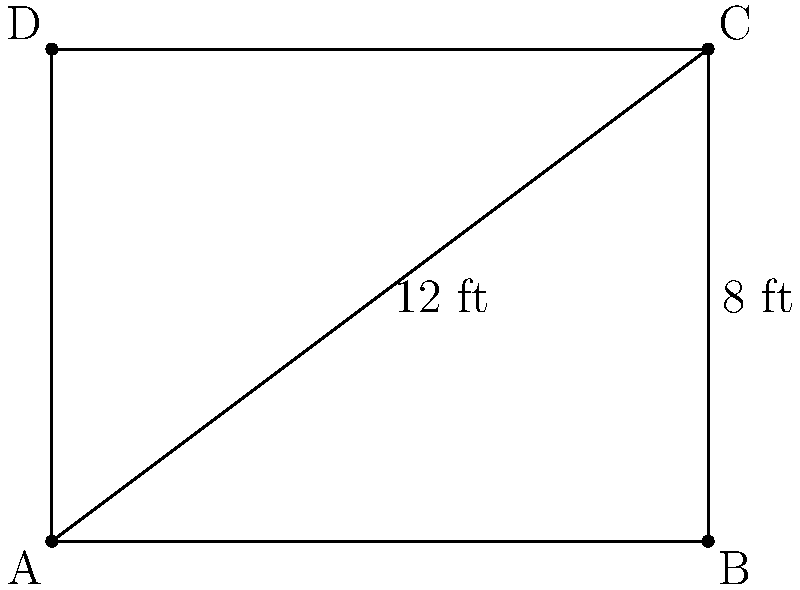As a tactics analyst, you're designing a new rectangular tactics board for Solskjær. The diagonal of the board measures 12 ft, and one side is 8 ft long. What is the area of the tactics board in square feet? Let's approach this step-by-step:

1) We know that the diagonal of a rectangle forms a right triangle with two sides of the rectangle.

2) Let's denote the unknown side as $x$ ft. We can use the Pythagorean theorem:

   $x^2 + 8^2 = 12^2$

3) Simplify:
   $x^2 + 64 = 144$

4) Subtract 64 from both sides:
   $x^2 = 80$

5) Take the square root of both sides:
   $x = \sqrt{80} = 4\sqrt{5} \approx 8.94$ ft

6) Now we have both dimensions of the rectangle. The area of a rectangle is given by length × width:

   $\text{Area} = 8 \times 4\sqrt{5}$

7) Simplify:
   $\text{Area} = 32\sqrt{5}$ sq ft

This is the exact answer. If we need to approximate:
$32\sqrt{5} \approx 71.55$ sq ft
Answer: $32\sqrt{5}$ sq ft 